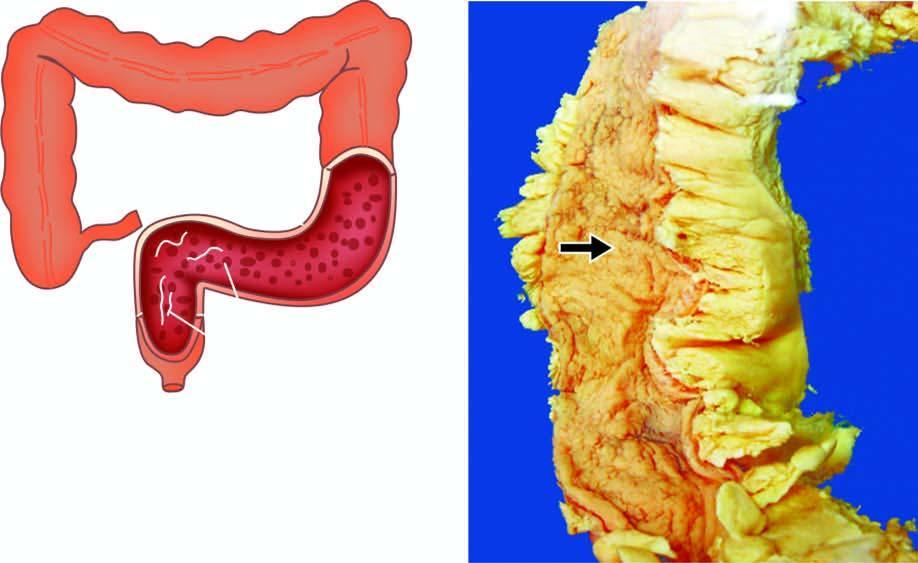what is narrow?
Answer the question using a single word or phrase. Lumen 